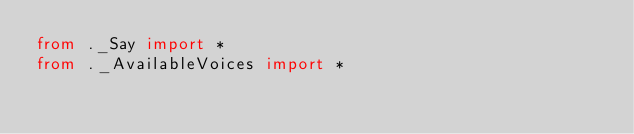Convert code to text. <code><loc_0><loc_0><loc_500><loc_500><_Python_>from ._Say import *
from ._AvailableVoices import *
</code> 